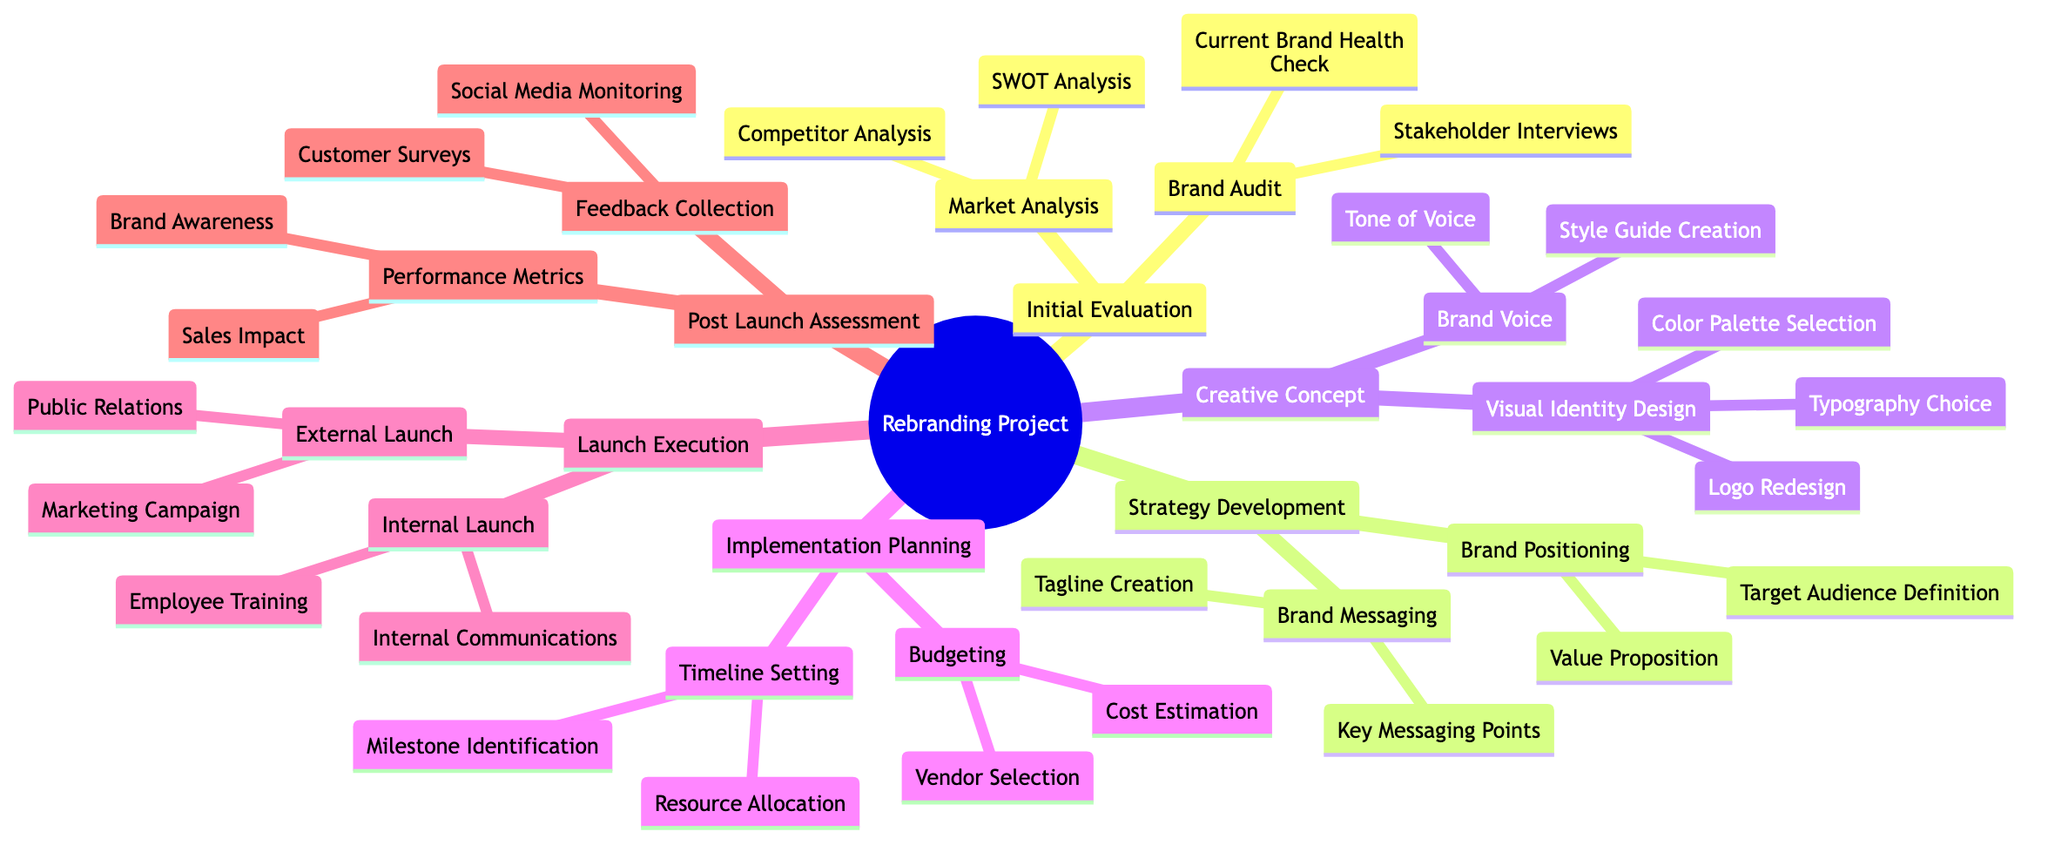What is the first stage of the rebranding project? The first stage in the family tree structure is identified as the topmost node under "Rebranding Project," which is "Initial Evaluation."
Answer: Initial Evaluation How many main stages are there in the rebranding project? The visual diagram displays six main stages branching out from the central node of "Rebranding Project," which are Initial Evaluation, Strategy Development, Creative Concept, Implementation Planning, Launch Execution, and Post Launch Assessment.
Answer: 6 What is a component of the Strategy Development stage? Upon examining the branches beneath the "Strategy Development" stage, "Brand Positioning" is one of the components listed in this stage, establishing its role in the rebranding project.
Answer: Brand Positioning Which analysis is part of the Market Analysis? By exploring the sub-nodes under "Market Analysis," both "Competitor Analysis" and "SWOT Analysis" are visible; however, selecting "SWOT Analysis" answers the question as a component of that stage.
Answer: SWOT Analysis How many components are under the Launch Execution stage? Analyzing the branches under the "Launch Execution" stage reveals two distinct components: "Internal Launch" and "External Launch." Therefore, the count of components is two.
Answer: 2 Which element focuses on the external aspect of launching a rebrand? Within the "Launch Execution" stage, "External Launch" is explicitly mentioned as the element dealing with the outward-facing tasks of rebranding, confirming its focus on external strategies.
Answer: External Launch How many elements are there under the Implementation Planning stage? The "Implementation Planning" stage consists of two main elements: "Timeline Setting" and "Budgeting," indicating that the total number of elements here equals two.
Answer: 2 What is a part of the Creative Concept stage regarding visual identity? The "Visual Identity Design" component, included in the "Creative Concept" stage, encompasses various focused tasks such as logo redesign and color palette selection, highlighting it as a crucial aspect of the creative process.
Answer: Visual Identity Design Which node would you associate with employee training? "Employee Training" is found under the "Internal Launch" section of the "Launch Execution" stage, illustrating its connection to the internal preparedness during a rebranding effort.
Answer: Employee Training 